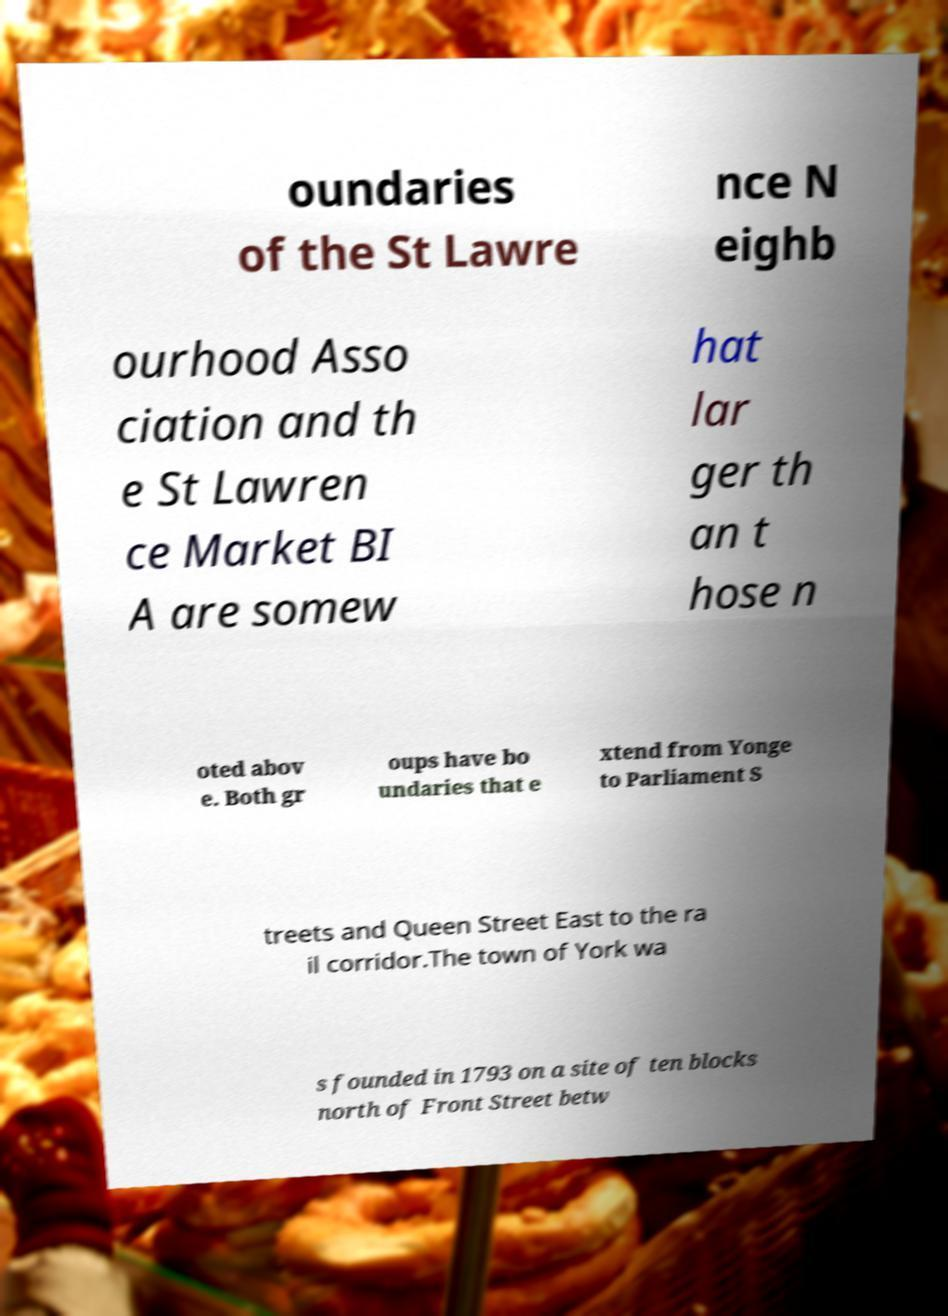Could you assist in decoding the text presented in this image and type it out clearly? oundaries of the St Lawre nce N eighb ourhood Asso ciation and th e St Lawren ce Market BI A are somew hat lar ger th an t hose n oted abov e. Both gr oups have bo undaries that e xtend from Yonge to Parliament S treets and Queen Street East to the ra il corridor.The town of York wa s founded in 1793 on a site of ten blocks north of Front Street betw 